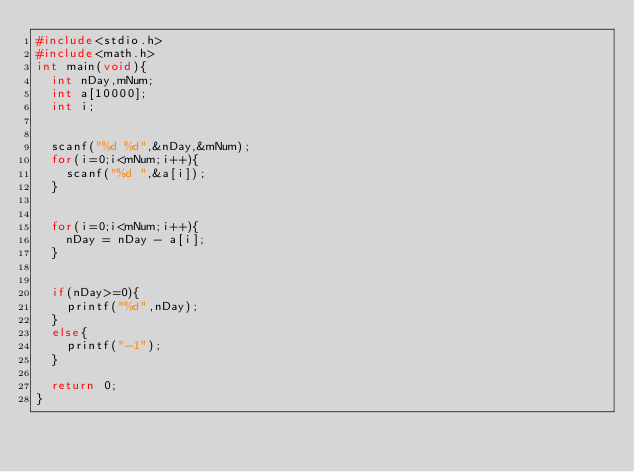Convert code to text. <code><loc_0><loc_0><loc_500><loc_500><_C_>#include<stdio.h>
#include<math.h>
int main(void){
  int nDay,mNum;
  int a[10000];
  int i;


  scanf("%d %d",&nDay,&mNum);
  for(i=0;i<mNum;i++){
    scanf("%d ",&a[i]); 
  }
  
  
  for(i=0;i<mNum;i++){
    nDay = nDay - a[i];
  }
  
  
  if(nDay>=0){
    printf("%d",nDay);
  }
  else{
    printf("-1");
  }
  
  return 0;
}
</code> 